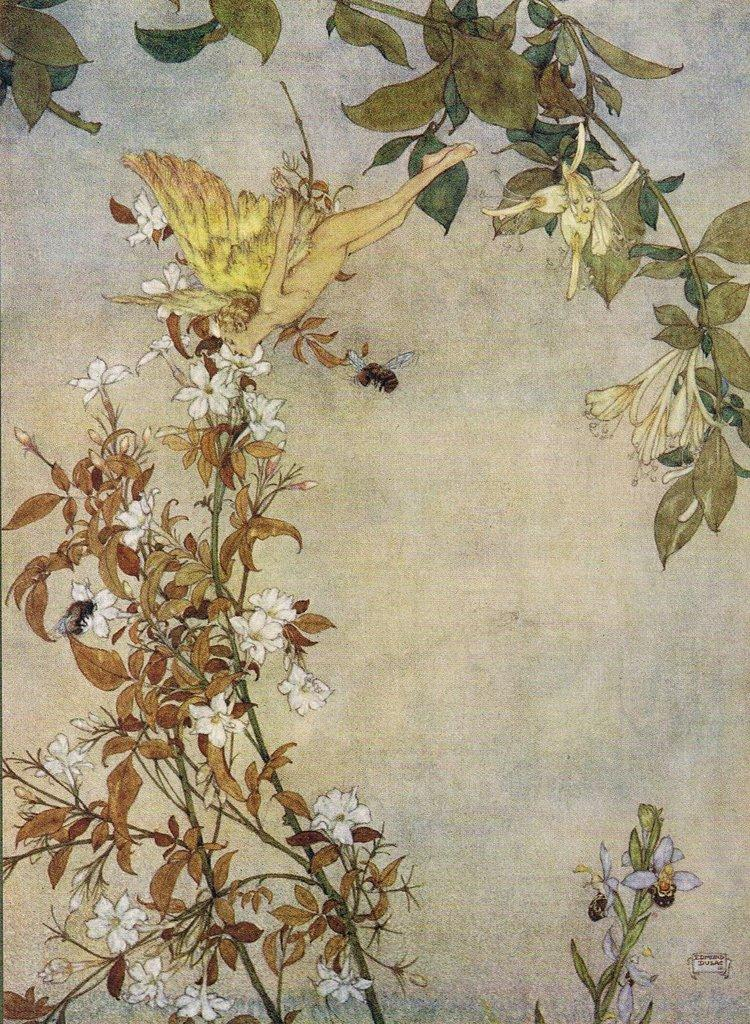What is the main subject of the art in the image? The image contains art that depicts plants, flowers, an insect, and a human with wings. Can you describe the plants in the art? The plants depicted in the art have flowers on them. What other living creature is present in the art? There is an insect depicted in the art. What is unique about the human depicted in the art? The human in the art has wings. What type of meal is being prepared in the art? There is no meal being prepared in the art; the image depicts art with plants, flowers, an insect, and a human with wings. Where is the faucet located in the art? There is no faucet present in the art; the image depicts art with plants, flowers, an insect, and a human with wings. 